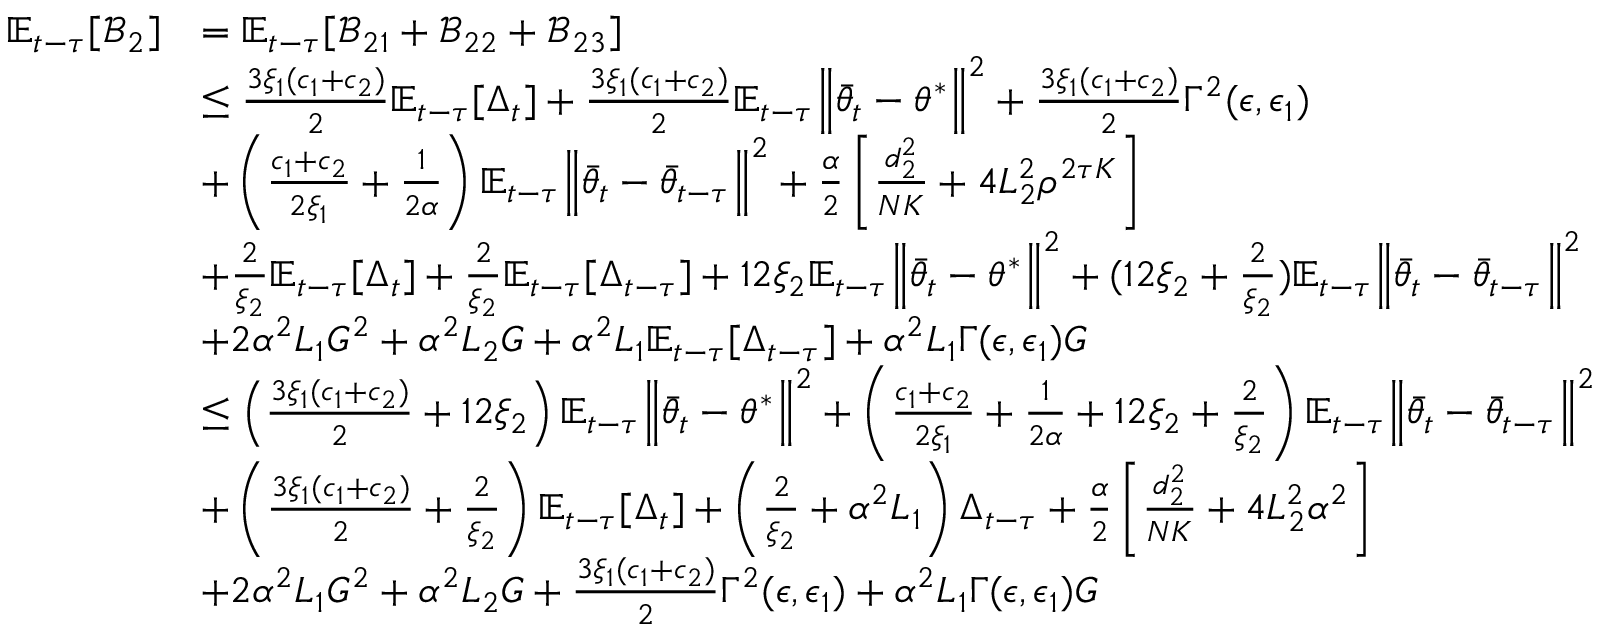<formula> <loc_0><loc_0><loc_500><loc_500>\begin{array} { r l } { \mathbb { E } _ { t - \tau } [ \mathcal { B } _ { 2 } ] } & { = \mathbb { E } _ { t - \tau } [ \mathcal { B } _ { 2 1 } + \mathcal { B } _ { 2 2 } + \mathcal { B } _ { 2 3 } ] } \\ & { \leq \frac { 3 \xi _ { 1 } ( c _ { 1 } + c _ { 2 } ) } { 2 } \mathbb { E } _ { t - \tau } [ \Delta _ { t } ] + \frac { 3 \xi _ { 1 } ( c _ { 1 } + c _ { 2 } ) } { 2 } \mathbb { E } _ { t - \tau } \left \| \bar { \theta } _ { t } - \theta ^ { * } \right \| ^ { 2 } + \frac { 3 \xi _ { 1 } ( c _ { 1 } + c _ { 2 } ) } { 2 } \Gamma ^ { 2 } ( \epsilon , \epsilon _ { 1 } ) } \\ & { + \left ( \frac { c _ { 1 } + c _ { 2 } } { 2 \xi _ { 1 } } + \frac { 1 } { 2 \alpha } \right ) \mathbb { E } _ { t - \tau } \left \| \bar { \theta } _ { t } - \bar { \theta } _ { t - \tau } \right \| ^ { 2 } + \frac { \alpha } { 2 } \left [ \frac { d _ { 2 } ^ { 2 } } { N K } + 4 L _ { 2 } ^ { 2 } \rho ^ { 2 \tau K } \right ] } \\ & { + \frac { 2 } { \xi _ { 2 } } \mathbb { E } _ { t - \tau } [ \Delta _ { t } ] + \frac { 2 } { \xi _ { 2 } } \mathbb { E } _ { t - \tau } [ \Delta _ { t - \tau } ] + 1 2 \xi _ { 2 } \mathbb { E } _ { t - \tau } \left \| \bar { \theta } _ { t } - \theta ^ { * } \right \| ^ { 2 } + ( 1 2 \xi _ { 2 } + \frac { 2 } { \xi _ { 2 } } ) \mathbb { E } _ { t - \tau } \left \| \bar { \theta } _ { t } - \bar { \theta } _ { t - \tau } \right \| ^ { 2 } } \\ & { + 2 \alpha ^ { 2 } L _ { 1 } G ^ { 2 } + \alpha ^ { 2 } L _ { 2 } G + \alpha ^ { 2 } L _ { 1 } \mathbb { E } _ { t - \tau } [ \Delta _ { t - \tau } ] + \alpha ^ { 2 } L _ { 1 } \Gamma ( \epsilon , \epsilon _ { 1 } ) G } \\ & { \leq \left ( \frac { 3 \xi _ { 1 } ( c _ { 1 } + c _ { 2 } ) } { 2 } + 1 2 \xi _ { 2 } \right ) \mathbb { E } _ { t - \tau } \left \| \bar { \theta } _ { t } - \theta ^ { * } \right \| ^ { 2 } + \left ( \frac { c _ { 1 } + c _ { 2 } } { 2 \xi _ { 1 } } + \frac { 1 } { 2 \alpha } + 1 2 \xi _ { 2 } + \frac { 2 } { \xi _ { 2 } } \right ) \mathbb { E } _ { t - \tau } \left \| \bar { \theta } _ { t } - \bar { \theta } _ { t - \tau } \right \| ^ { 2 } } \\ & { + \left ( \frac { 3 \xi _ { 1 } ( c _ { 1 } + c _ { 2 } ) } { 2 } + \frac { 2 } { \xi _ { 2 } } \right ) \mathbb { E } _ { t - \tau } [ \Delta _ { t } ] + \left ( \frac { 2 } { \xi _ { 2 } } + \alpha ^ { 2 } L _ { 1 } \right ) \Delta _ { t - \tau } + \frac { \alpha } { 2 } \left [ \frac { d _ { 2 } ^ { 2 } } { N K } + 4 L _ { 2 } ^ { 2 } \alpha ^ { 2 } \right ] } \\ & { + 2 \alpha ^ { 2 } L _ { 1 } G ^ { 2 } + \alpha ^ { 2 } L _ { 2 } G + \frac { 3 \xi _ { 1 } ( c _ { 1 } + c _ { 2 } ) } { 2 } \Gamma ^ { 2 } ( \epsilon , \epsilon _ { 1 } ) + \alpha ^ { 2 } L _ { 1 } \Gamma ( \epsilon , \epsilon _ { 1 } ) G } \end{array}</formula> 